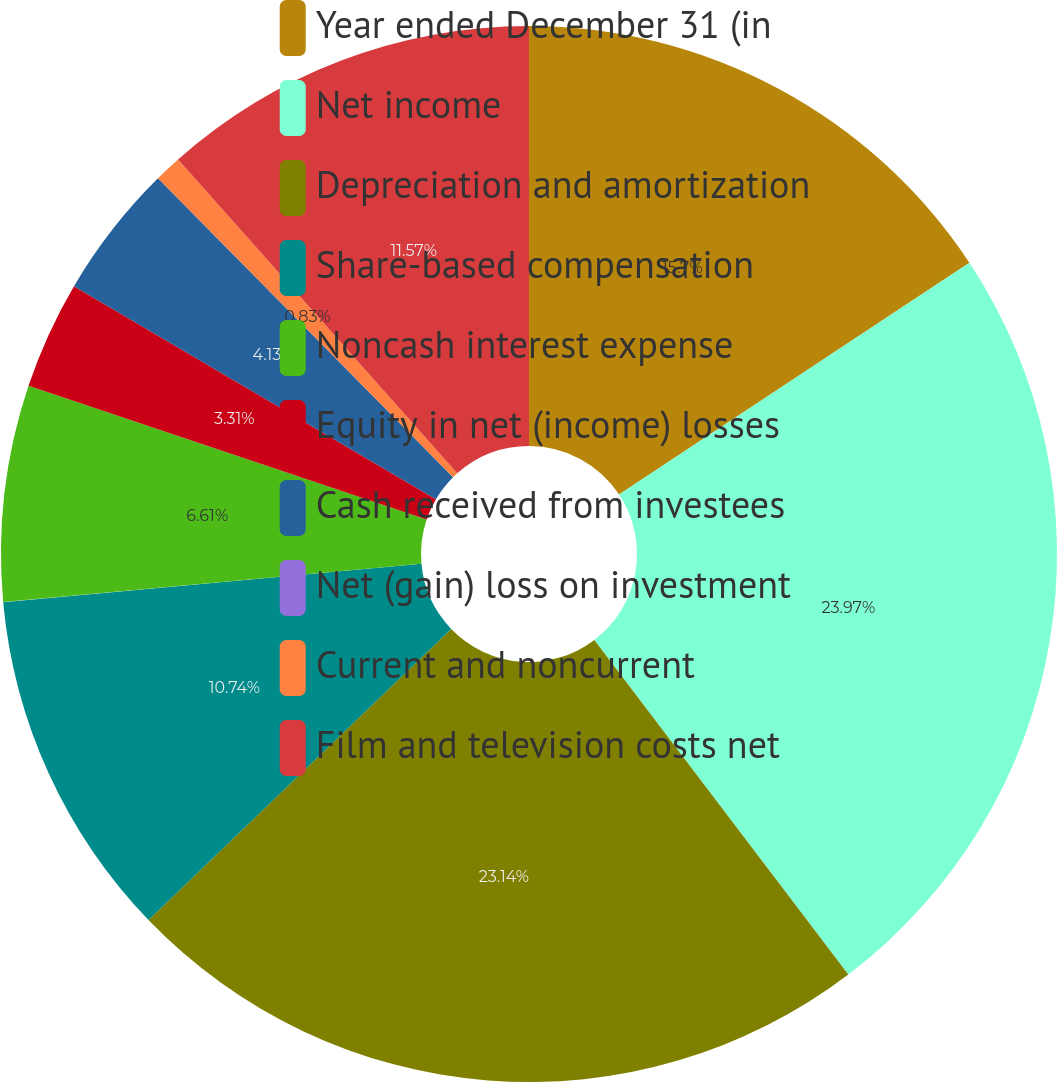Convert chart. <chart><loc_0><loc_0><loc_500><loc_500><pie_chart><fcel>Year ended December 31 (in<fcel>Net income<fcel>Depreciation and amortization<fcel>Share-based compensation<fcel>Noncash interest expense<fcel>Equity in net (income) losses<fcel>Cash received from investees<fcel>Net (gain) loss on investment<fcel>Current and noncurrent<fcel>Film and television costs net<nl><fcel>15.7%<fcel>23.96%<fcel>23.14%<fcel>10.74%<fcel>6.61%<fcel>3.31%<fcel>4.13%<fcel>0.0%<fcel>0.83%<fcel>11.57%<nl></chart> 